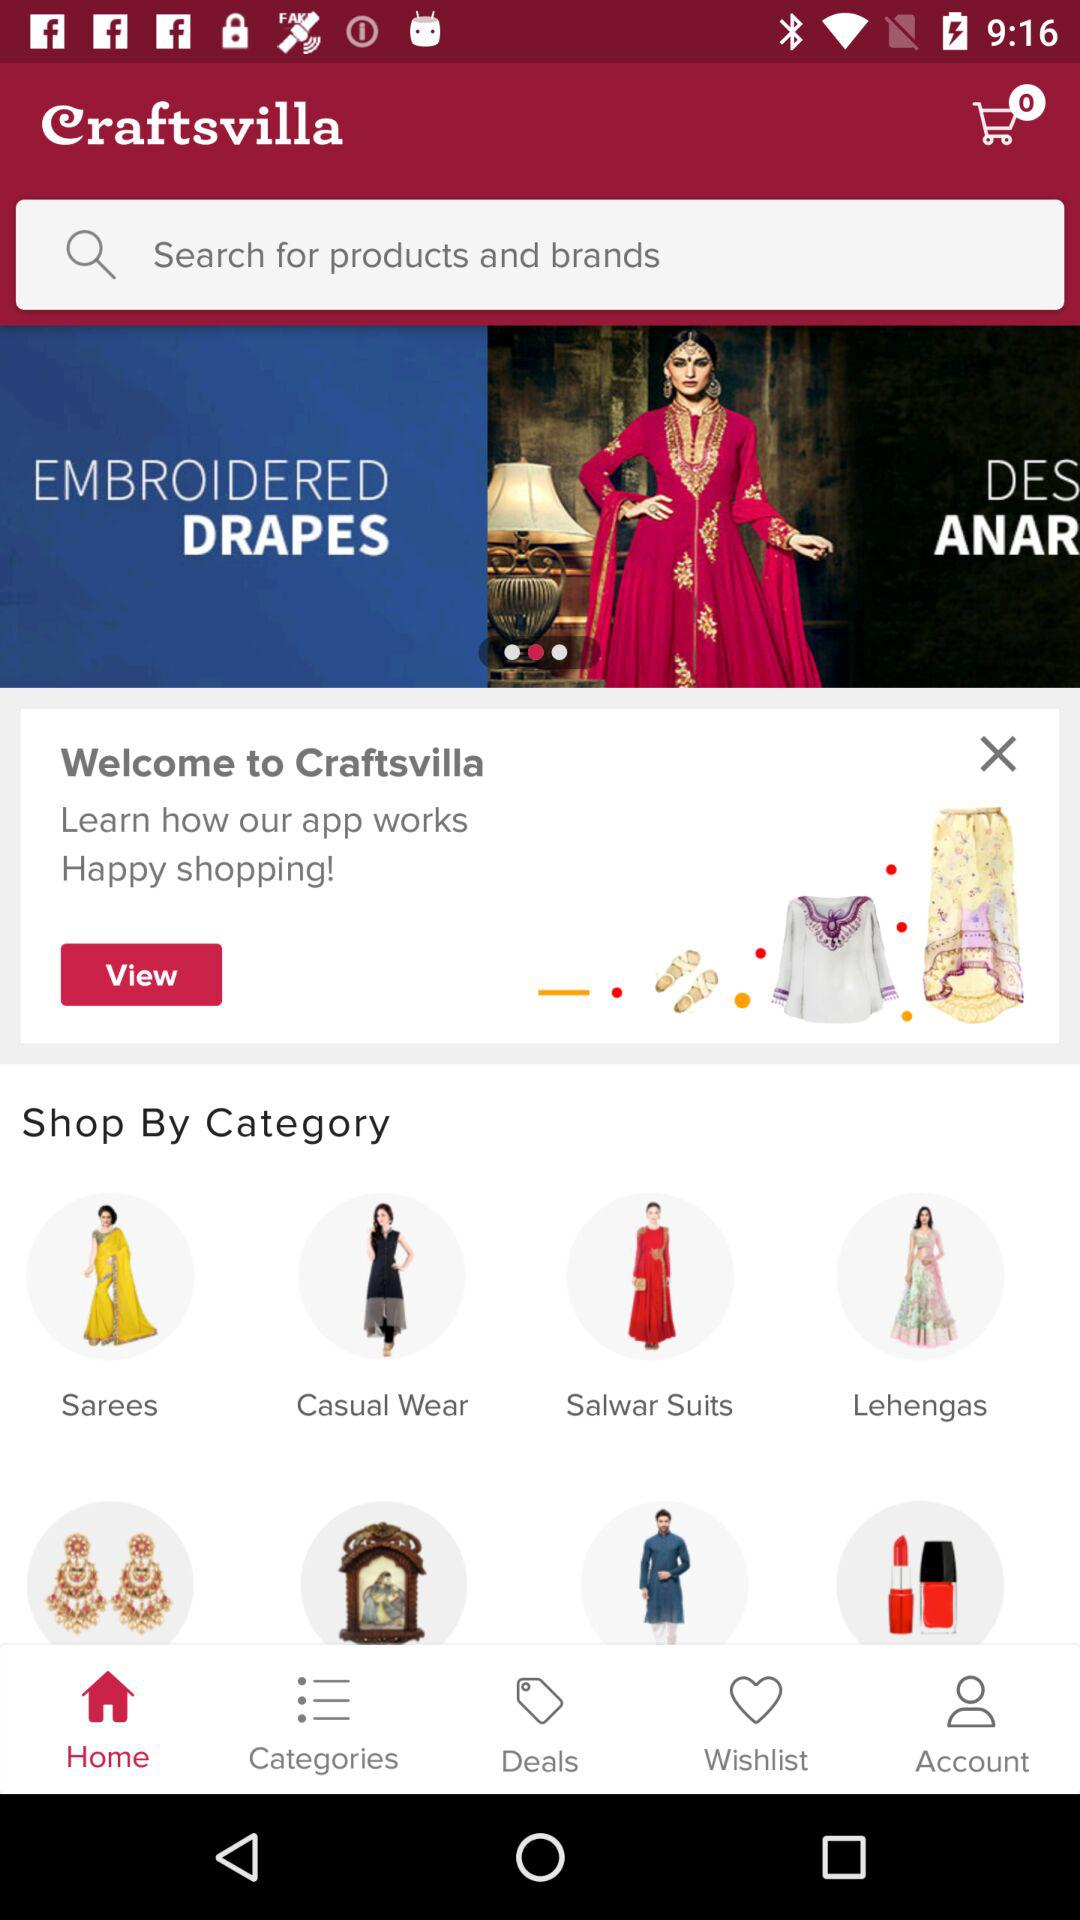What is the application name? The application name is "Craftsvilla". 